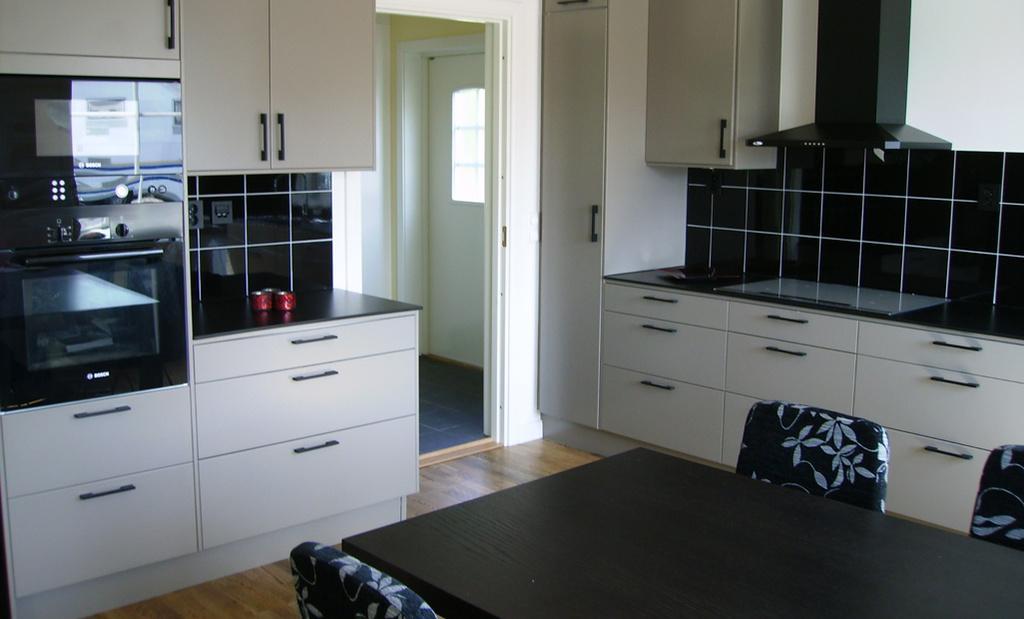In one or two sentences, can you explain what this image depicts? In this picture there is a kitchen in which there is a chimney, cupboard, dining table and some chairs here. There is a oven and some desks here. We can observe a entrance in the background. 